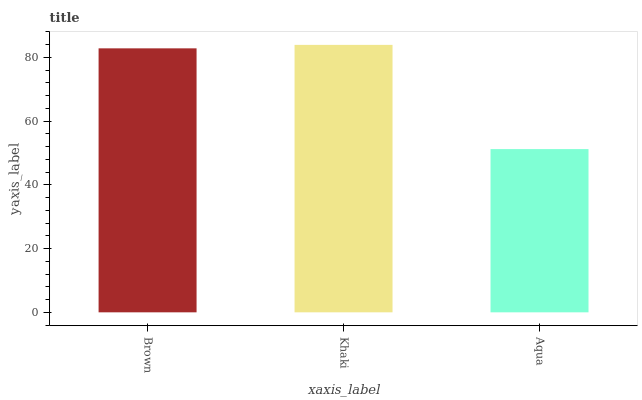Is Aqua the minimum?
Answer yes or no. Yes. Is Khaki the maximum?
Answer yes or no. Yes. Is Khaki the minimum?
Answer yes or no. No. Is Aqua the maximum?
Answer yes or no. No. Is Khaki greater than Aqua?
Answer yes or no. Yes. Is Aqua less than Khaki?
Answer yes or no. Yes. Is Aqua greater than Khaki?
Answer yes or no. No. Is Khaki less than Aqua?
Answer yes or no. No. Is Brown the high median?
Answer yes or no. Yes. Is Brown the low median?
Answer yes or no. Yes. Is Khaki the high median?
Answer yes or no. No. Is Aqua the low median?
Answer yes or no. No. 